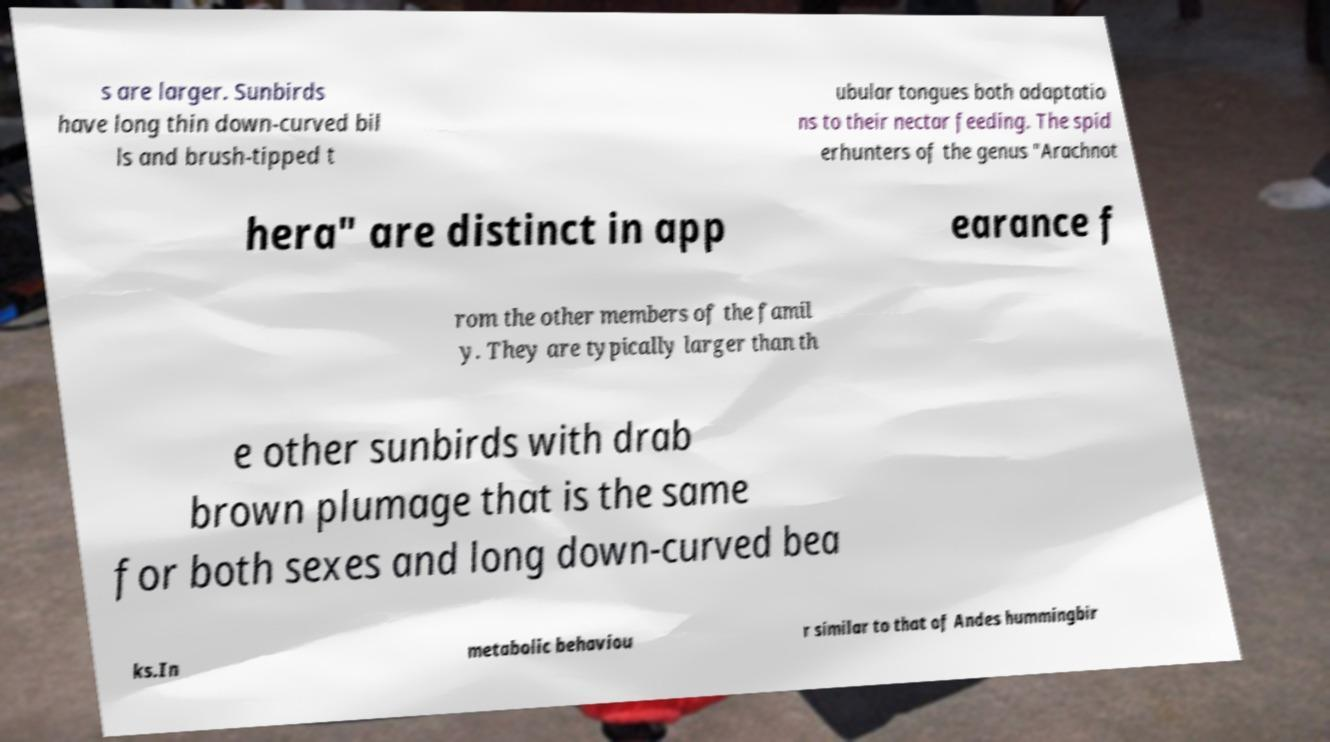Please identify and transcribe the text found in this image. s are larger. Sunbirds have long thin down-curved bil ls and brush-tipped t ubular tongues both adaptatio ns to their nectar feeding. The spid erhunters of the genus "Arachnot hera" are distinct in app earance f rom the other members of the famil y. They are typically larger than th e other sunbirds with drab brown plumage that is the same for both sexes and long down-curved bea ks.In metabolic behaviou r similar to that of Andes hummingbir 